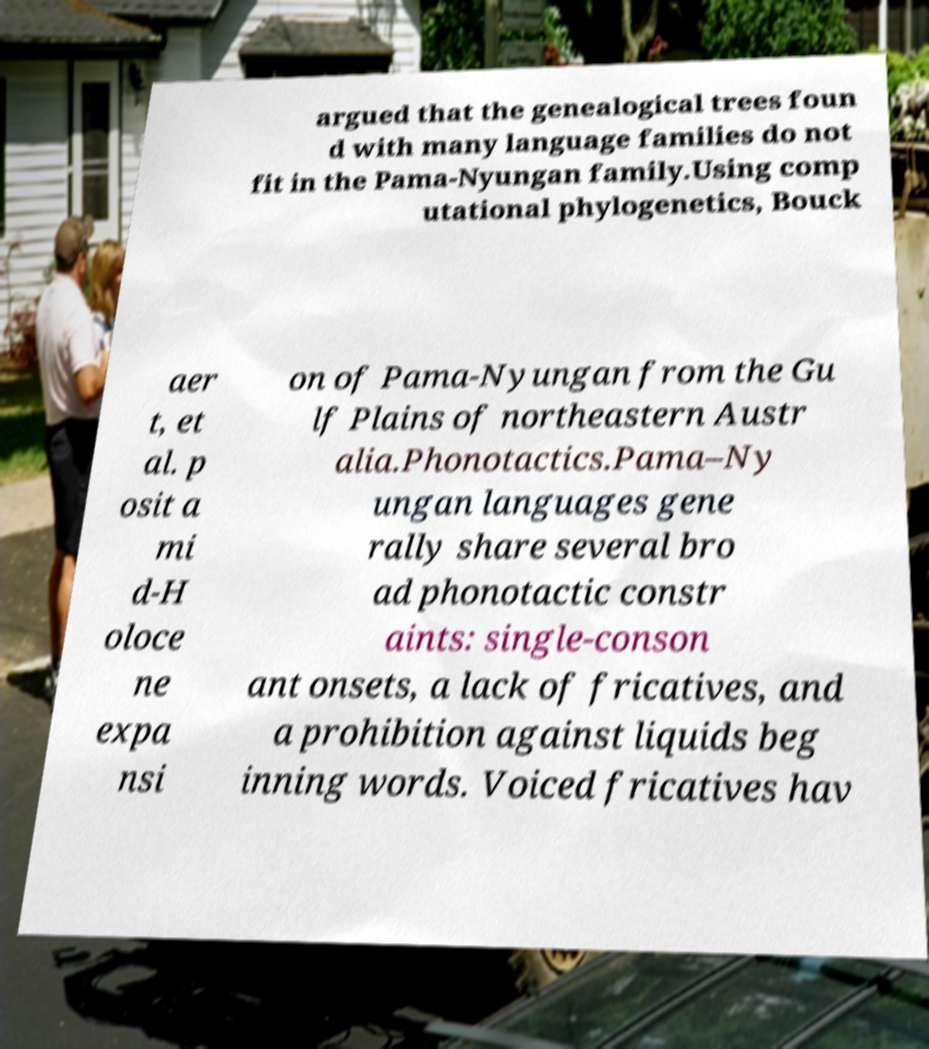Can you read and provide the text displayed in the image?This photo seems to have some interesting text. Can you extract and type it out for me? argued that the genealogical trees foun d with many language families do not fit in the Pama-Nyungan family.Using comp utational phylogenetics, Bouck aer t, et al. p osit a mi d-H oloce ne expa nsi on of Pama-Nyungan from the Gu lf Plains of northeastern Austr alia.Phonotactics.Pama–Ny ungan languages gene rally share several bro ad phonotactic constr aints: single-conson ant onsets, a lack of fricatives, and a prohibition against liquids beg inning words. Voiced fricatives hav 